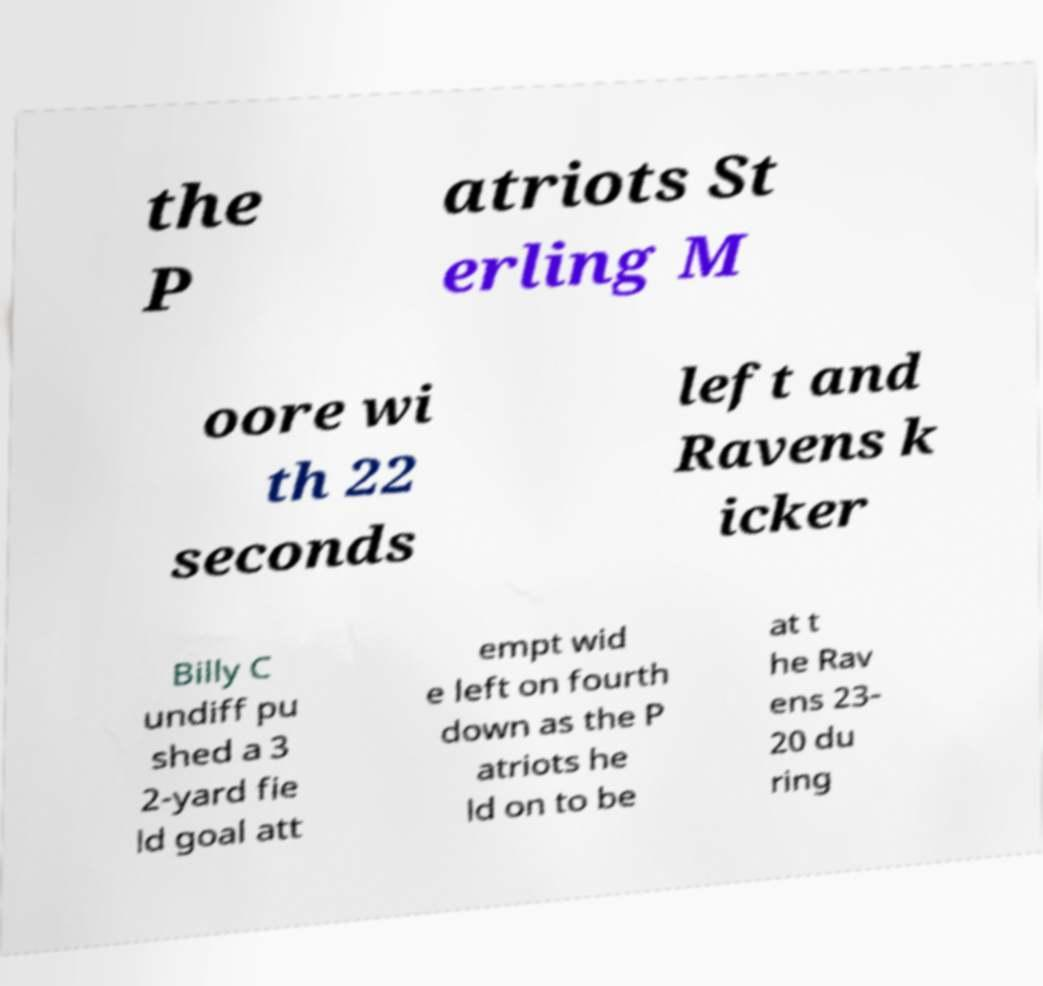What messages or text are displayed in this image? I need them in a readable, typed format. the P atriots St erling M oore wi th 22 seconds left and Ravens k icker Billy C undiff pu shed a 3 2-yard fie ld goal att empt wid e left on fourth down as the P atriots he ld on to be at t he Rav ens 23- 20 du ring 